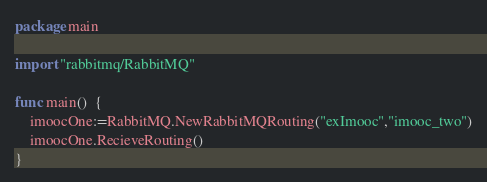Convert code to text. <code><loc_0><loc_0><loc_500><loc_500><_Go_>package main

import "rabbitmq/RabbitMQ"

func main()  {
	imoocOne:=RabbitMQ.NewRabbitMQRouting("exImooc","imooc_two")
	imoocOne.RecieveRouting()
}
</code> 